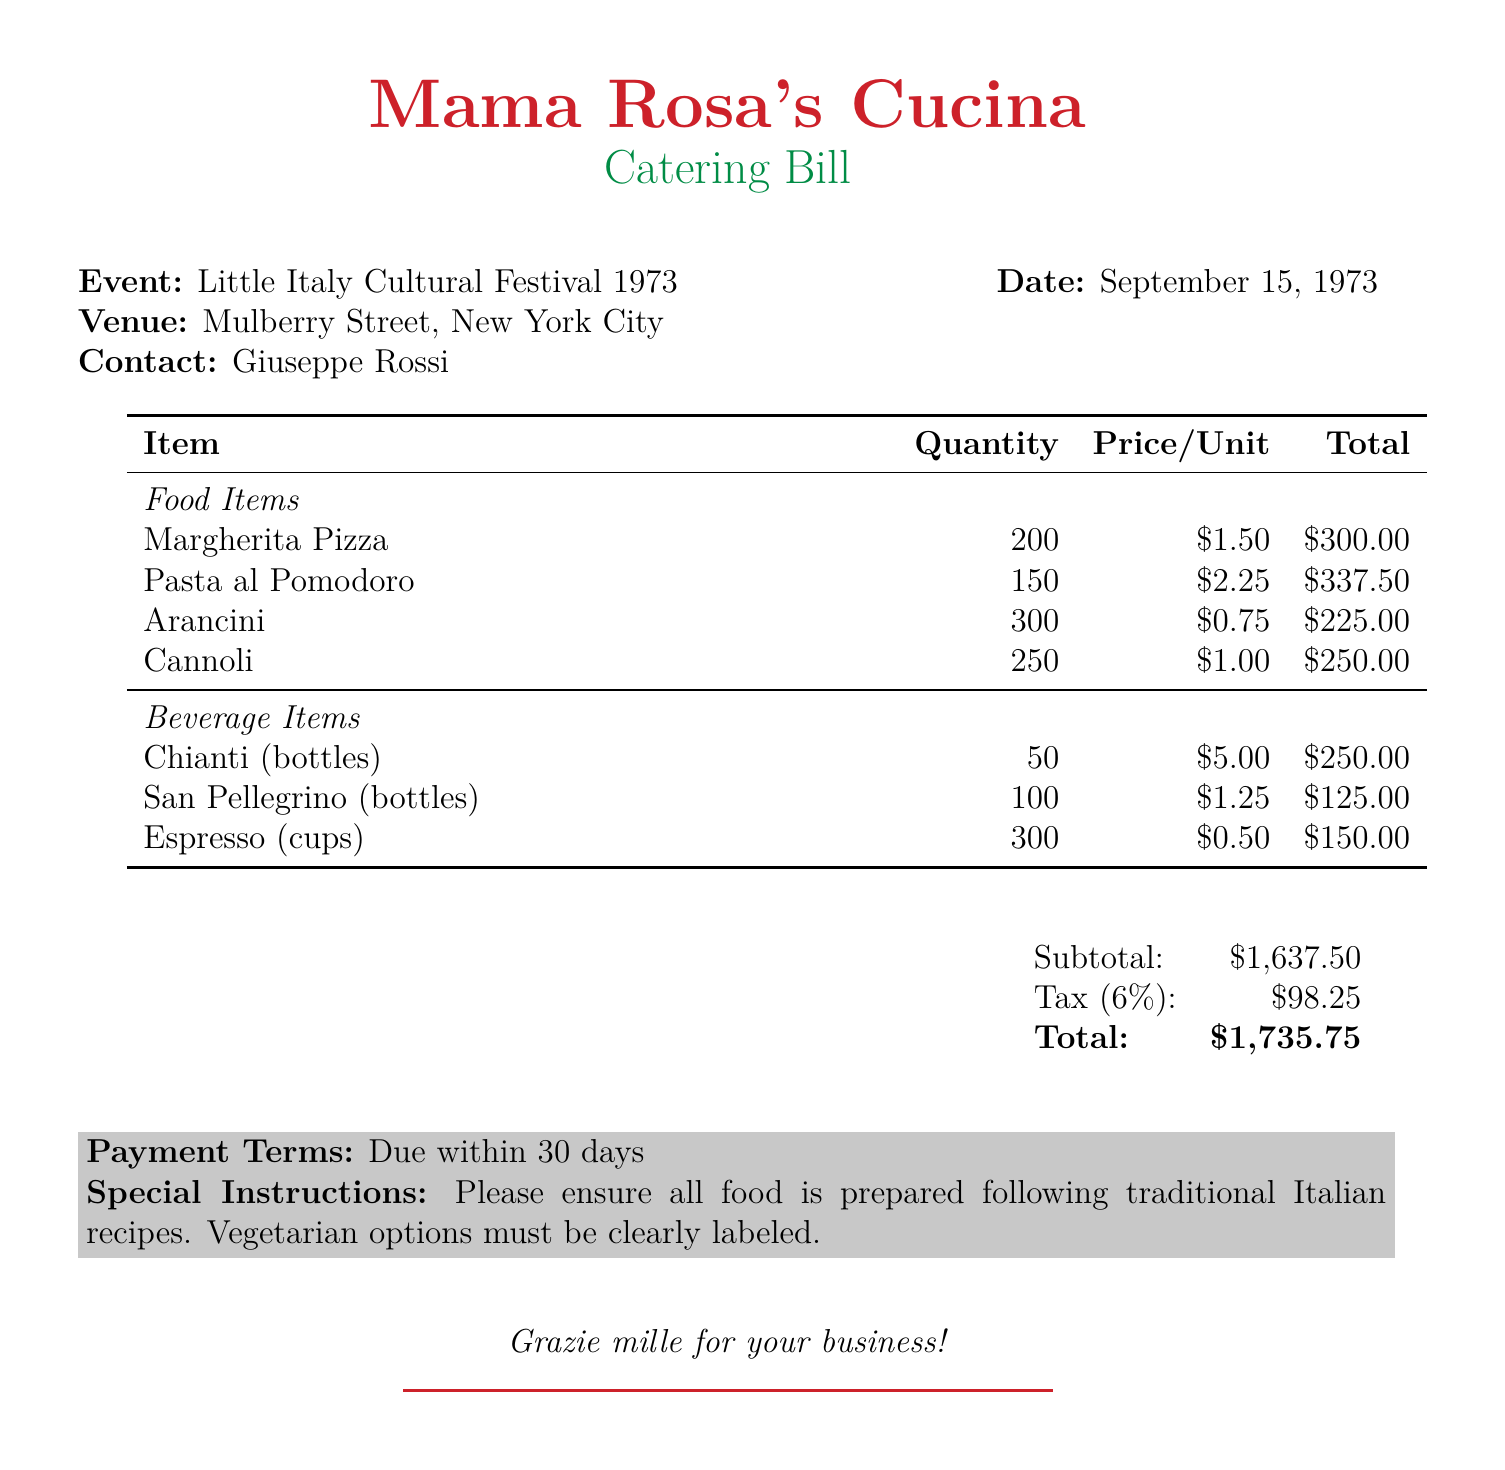What is the total amount due? The total amount due is listed at the bottom of the bill as the final total including tax.
Answer: $1,735.75 What date is the event scheduled? The bill specifies that the event takes place on September 15, 1973.
Answer: September 15, 1973 Who is the contact person for the catering event? The document lists Giuseppe Rossi as the contact person for the event.
Answer: Giuseppe Rossi How many bottles of Chianti are included? The quantity of Chianti bottles is detailed in the beverage section of the bill.
Answer: 50 What is the tax rate applied to the subtotal? The tax is given as a percentage of the subtotal, which can be found within the bill.
Answer: 6% What is the price of a Cannolo? The price per Cannolo is specified in the food items section of the document.
Answer: $1.00 How many Arancini were ordered? The total quantity of Arancini is provided in the food items section.
Answer: 300 What instruction is given regarding vegetarian options? The document outlines special instructions concerning food labeling.
Answer: Must be clearly labeled What are the payment terms? The bill states the terms under which payment should be made, which are provided at the bottom.
Answer: Due within 30 days 